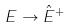Convert formula to latex. <formula><loc_0><loc_0><loc_500><loc_500>E \rightarrow \hat { E } ^ { + }</formula> 